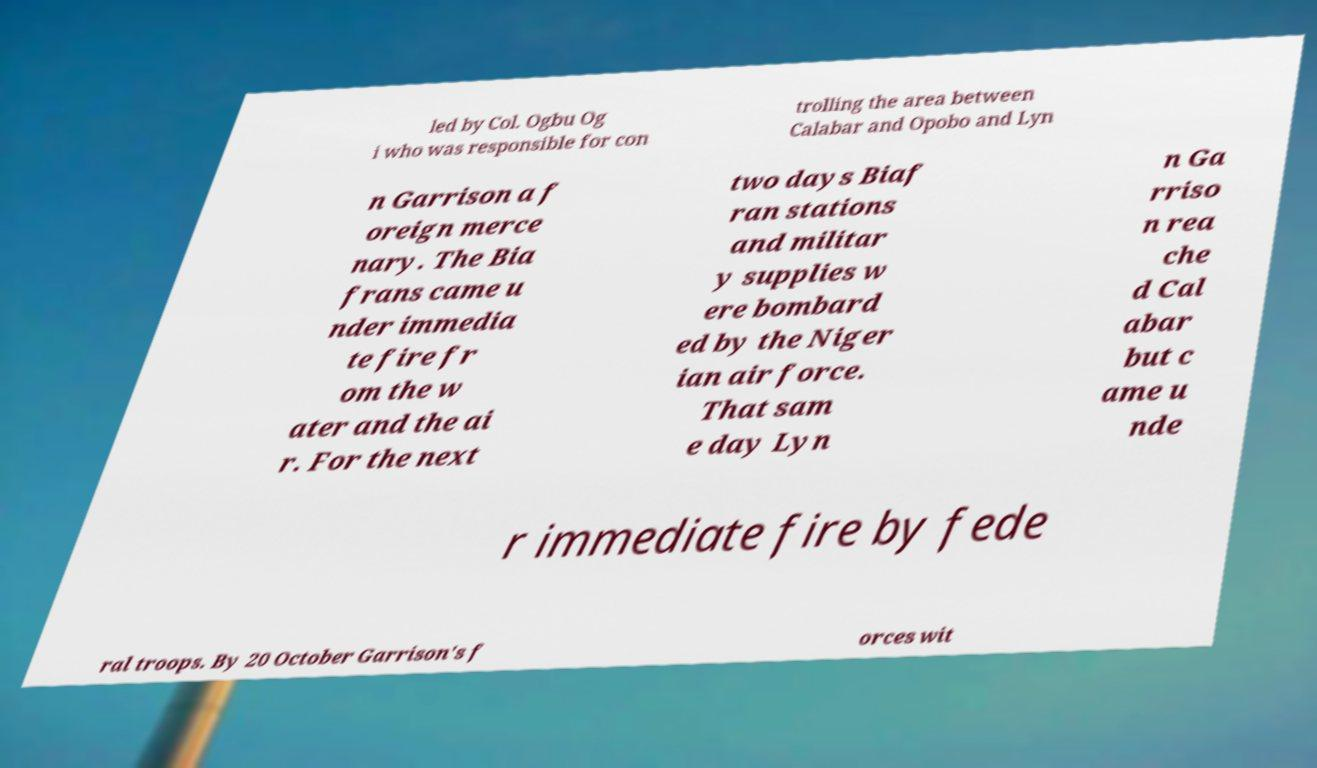Please read and relay the text visible in this image. What does it say? led by Col. Ogbu Og i who was responsible for con trolling the area between Calabar and Opobo and Lyn n Garrison a f oreign merce nary. The Bia frans came u nder immedia te fire fr om the w ater and the ai r. For the next two days Biaf ran stations and militar y supplies w ere bombard ed by the Niger ian air force. That sam e day Lyn n Ga rriso n rea che d Cal abar but c ame u nde r immediate fire by fede ral troops. By 20 October Garrison's f orces wit 